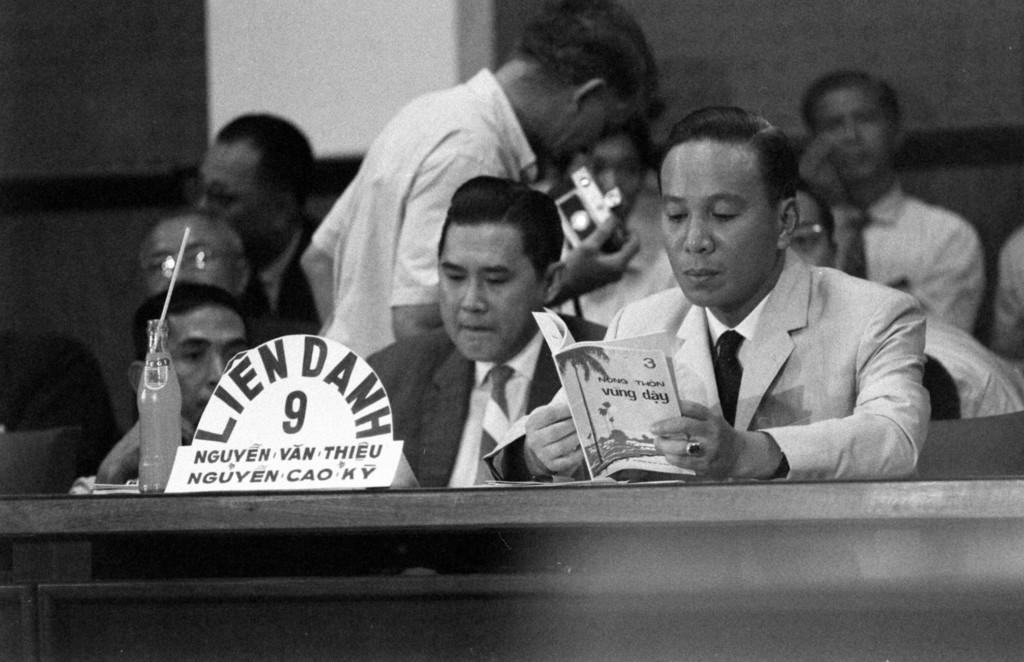What are the people in the image doing? There are people sitting in the image. Can you describe the activity of one of the people? A person is reading a book. What else can be seen in the image besides the people? There is a cool drink bottle in the image. What type of nail is being used to control the book in the image? There is no nail present in the image, and the book is not being controlled by any object. 